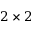<formula> <loc_0><loc_0><loc_500><loc_500>2 \times 2</formula> 